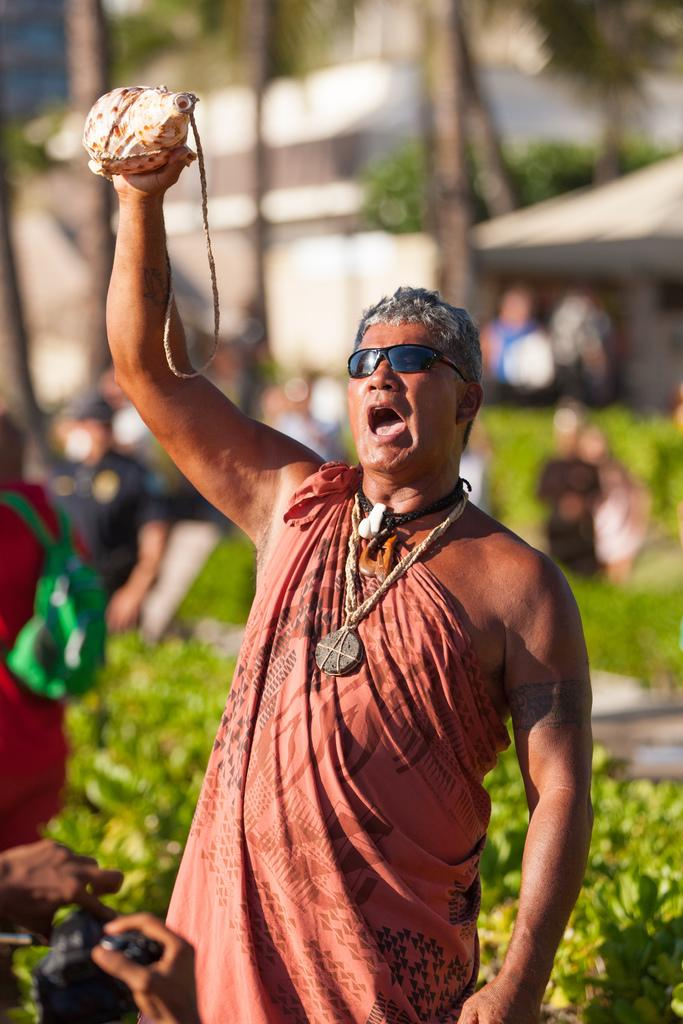What is the person in the foreground doing in the image? The person in the foreground is holding an object in their hand. What can be seen in the background of the image? In the background, there is a crowd, planets, houses, and trees. Can you describe the time of day when the image was taken? The image was taken during the day. What type of tail can be seen on the person in the image? There is no tail visible on the person in the image. What kind of cup is being used by the person in the image? The person in the image is not using a cup; they are holding an unspecified object in their hand. 